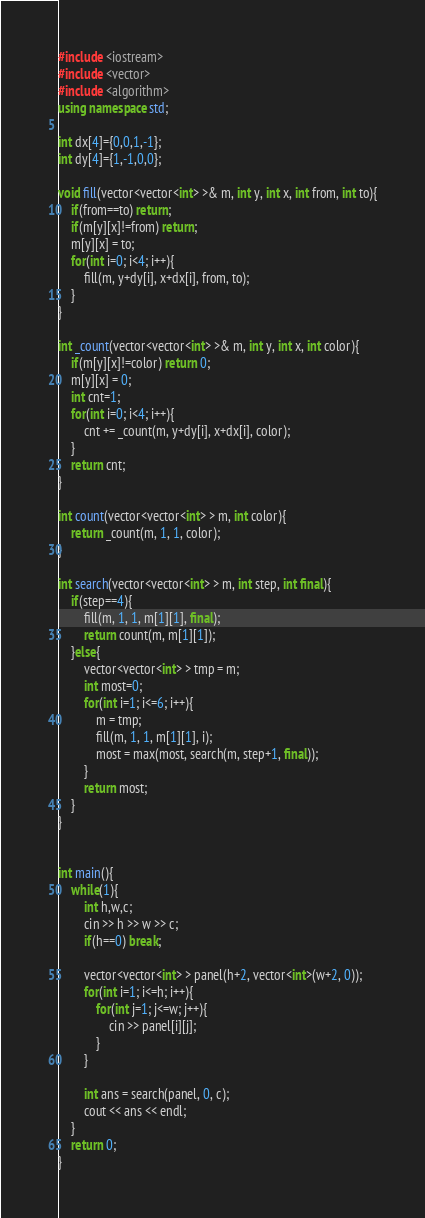Convert code to text. <code><loc_0><loc_0><loc_500><loc_500><_C++_>#include <iostream>
#include <vector>
#include <algorithm>
using namespace std;

int dx[4]={0,0,1,-1};
int dy[4]={1,-1,0,0};

void fill(vector<vector<int> >& m, int y, int x, int from, int to){
    if(from==to) return;
    if(m[y][x]!=from) return;
    m[y][x] = to;
    for(int i=0; i<4; i++){
        fill(m, y+dy[i], x+dx[i], from, to);
    }
}

int _count(vector<vector<int> >& m, int y, int x, int color){
    if(m[y][x]!=color) return 0;
    m[y][x] = 0;
    int cnt=1;
    for(int i=0; i<4; i++){
        cnt += _count(m, y+dy[i], x+dx[i], color);
    }
    return cnt;
}

int count(vector<vector<int> > m, int color){
    return _count(m, 1, 1, color);
}

int search(vector<vector<int> > m, int step, int final){
    if(step==4){
        fill(m, 1, 1, m[1][1], final);
        return count(m, m[1][1]);
    }else{
        vector<vector<int> > tmp = m;
        int most=0;
        for(int i=1; i<=6; i++){
            m = tmp;
            fill(m, 1, 1, m[1][1], i);
            most = max(most, search(m, step+1, final));
        }
        return most;
    }
}
    

int main(){
    while(1){
        int h,w,c;
        cin >> h >> w >> c;
        if(h==0) break;

        vector<vector<int> > panel(h+2, vector<int>(w+2, 0));
        for(int i=1; i<=h; i++){
            for(int j=1; j<=w; j++){
                cin >> panel[i][j];
            }
        }

        int ans = search(panel, 0, c);
        cout << ans << endl;
    }
    return 0;
}</code> 